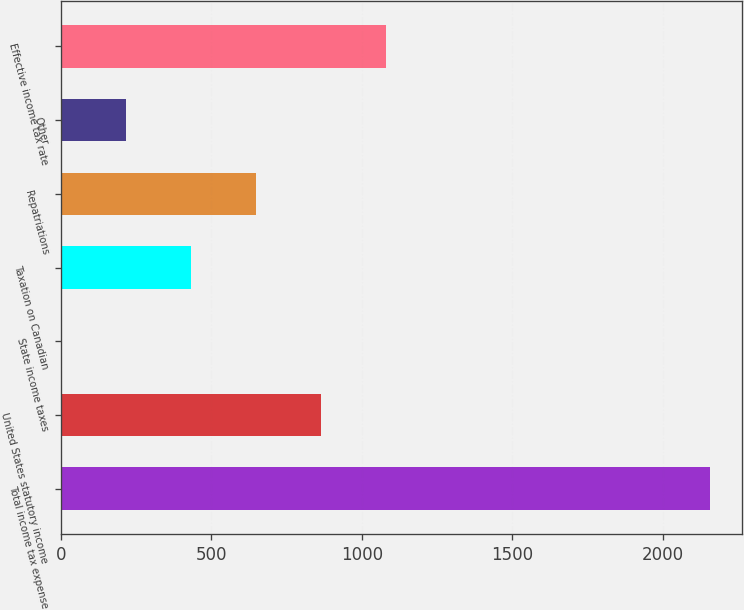Convert chart to OTSL. <chart><loc_0><loc_0><loc_500><loc_500><bar_chart><fcel>Total income tax expense<fcel>United States statutory income<fcel>State income taxes<fcel>Taxation on Canadian<fcel>Repatriations<fcel>Other<fcel>Effective income tax rate<nl><fcel>2156<fcel>863<fcel>1<fcel>432<fcel>647.5<fcel>216.5<fcel>1078.5<nl></chart> 